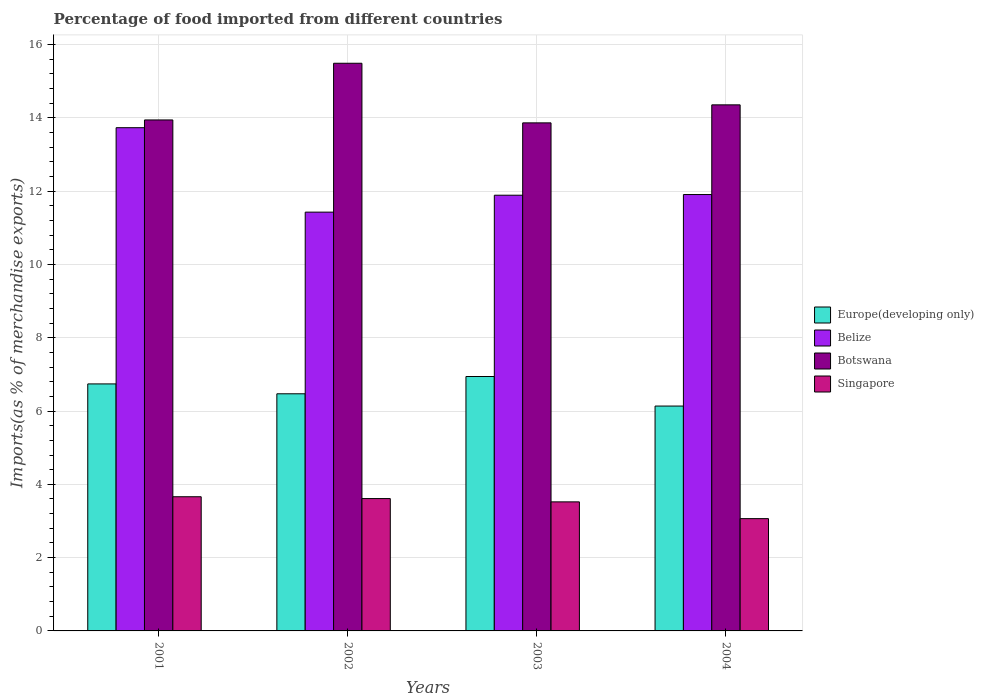How many groups of bars are there?
Give a very brief answer. 4. How many bars are there on the 4th tick from the left?
Ensure brevity in your answer.  4. What is the percentage of imports to different countries in Europe(developing only) in 2001?
Give a very brief answer. 6.74. Across all years, what is the maximum percentage of imports to different countries in Belize?
Keep it short and to the point. 13.73. Across all years, what is the minimum percentage of imports to different countries in Belize?
Provide a short and direct response. 11.43. In which year was the percentage of imports to different countries in Europe(developing only) minimum?
Provide a short and direct response. 2004. What is the total percentage of imports to different countries in Belize in the graph?
Make the answer very short. 48.96. What is the difference between the percentage of imports to different countries in Europe(developing only) in 2002 and that in 2004?
Provide a succinct answer. 0.33. What is the difference between the percentage of imports to different countries in Singapore in 2003 and the percentage of imports to different countries in Europe(developing only) in 2002?
Ensure brevity in your answer.  -2.95. What is the average percentage of imports to different countries in Europe(developing only) per year?
Provide a short and direct response. 6.57. In the year 2001, what is the difference between the percentage of imports to different countries in Belize and percentage of imports to different countries in Singapore?
Your answer should be very brief. 10.07. In how many years, is the percentage of imports to different countries in Belize greater than 13.6 %?
Your answer should be very brief. 1. What is the ratio of the percentage of imports to different countries in Belize in 2001 to that in 2003?
Your answer should be compact. 1.15. What is the difference between the highest and the second highest percentage of imports to different countries in Singapore?
Make the answer very short. 0.05. What is the difference between the highest and the lowest percentage of imports to different countries in Botswana?
Your answer should be very brief. 1.63. Is it the case that in every year, the sum of the percentage of imports to different countries in Botswana and percentage of imports to different countries in Belize is greater than the sum of percentage of imports to different countries in Singapore and percentage of imports to different countries in Europe(developing only)?
Provide a short and direct response. Yes. What does the 3rd bar from the left in 2003 represents?
Offer a very short reply. Botswana. What does the 4th bar from the right in 2002 represents?
Give a very brief answer. Europe(developing only). What is the difference between two consecutive major ticks on the Y-axis?
Keep it short and to the point. 2. Does the graph contain any zero values?
Keep it short and to the point. No. Does the graph contain grids?
Provide a short and direct response. Yes. Where does the legend appear in the graph?
Provide a short and direct response. Center right. What is the title of the graph?
Your answer should be compact. Percentage of food imported from different countries. What is the label or title of the X-axis?
Give a very brief answer. Years. What is the label or title of the Y-axis?
Offer a very short reply. Imports(as % of merchandise exports). What is the Imports(as % of merchandise exports) in Europe(developing only) in 2001?
Your answer should be very brief. 6.74. What is the Imports(as % of merchandise exports) of Belize in 2001?
Your answer should be very brief. 13.73. What is the Imports(as % of merchandise exports) of Botswana in 2001?
Give a very brief answer. 13.94. What is the Imports(as % of merchandise exports) of Singapore in 2001?
Offer a terse response. 3.66. What is the Imports(as % of merchandise exports) in Europe(developing only) in 2002?
Provide a succinct answer. 6.47. What is the Imports(as % of merchandise exports) of Belize in 2002?
Your response must be concise. 11.43. What is the Imports(as % of merchandise exports) of Botswana in 2002?
Your answer should be compact. 15.49. What is the Imports(as % of merchandise exports) of Singapore in 2002?
Your response must be concise. 3.61. What is the Imports(as % of merchandise exports) of Europe(developing only) in 2003?
Your response must be concise. 6.94. What is the Imports(as % of merchandise exports) of Belize in 2003?
Provide a succinct answer. 11.89. What is the Imports(as % of merchandise exports) in Botswana in 2003?
Your answer should be compact. 13.86. What is the Imports(as % of merchandise exports) in Singapore in 2003?
Provide a succinct answer. 3.52. What is the Imports(as % of merchandise exports) of Europe(developing only) in 2004?
Your answer should be compact. 6.14. What is the Imports(as % of merchandise exports) of Belize in 2004?
Offer a terse response. 11.91. What is the Imports(as % of merchandise exports) in Botswana in 2004?
Offer a terse response. 14.36. What is the Imports(as % of merchandise exports) in Singapore in 2004?
Your answer should be very brief. 3.06. Across all years, what is the maximum Imports(as % of merchandise exports) in Europe(developing only)?
Your response must be concise. 6.94. Across all years, what is the maximum Imports(as % of merchandise exports) of Belize?
Your response must be concise. 13.73. Across all years, what is the maximum Imports(as % of merchandise exports) of Botswana?
Make the answer very short. 15.49. Across all years, what is the maximum Imports(as % of merchandise exports) in Singapore?
Ensure brevity in your answer.  3.66. Across all years, what is the minimum Imports(as % of merchandise exports) in Europe(developing only)?
Provide a short and direct response. 6.14. Across all years, what is the minimum Imports(as % of merchandise exports) of Belize?
Ensure brevity in your answer.  11.43. Across all years, what is the minimum Imports(as % of merchandise exports) of Botswana?
Ensure brevity in your answer.  13.86. Across all years, what is the minimum Imports(as % of merchandise exports) in Singapore?
Give a very brief answer. 3.06. What is the total Imports(as % of merchandise exports) of Europe(developing only) in the graph?
Offer a very short reply. 26.29. What is the total Imports(as % of merchandise exports) in Belize in the graph?
Offer a terse response. 48.96. What is the total Imports(as % of merchandise exports) of Botswana in the graph?
Provide a short and direct response. 57.65. What is the total Imports(as % of merchandise exports) of Singapore in the graph?
Provide a succinct answer. 13.86. What is the difference between the Imports(as % of merchandise exports) of Europe(developing only) in 2001 and that in 2002?
Make the answer very short. 0.27. What is the difference between the Imports(as % of merchandise exports) of Belize in 2001 and that in 2002?
Your response must be concise. 2.3. What is the difference between the Imports(as % of merchandise exports) in Botswana in 2001 and that in 2002?
Provide a succinct answer. -1.55. What is the difference between the Imports(as % of merchandise exports) of Singapore in 2001 and that in 2002?
Your answer should be very brief. 0.05. What is the difference between the Imports(as % of merchandise exports) in Europe(developing only) in 2001 and that in 2003?
Make the answer very short. -0.2. What is the difference between the Imports(as % of merchandise exports) of Belize in 2001 and that in 2003?
Your answer should be very brief. 1.84. What is the difference between the Imports(as % of merchandise exports) of Botswana in 2001 and that in 2003?
Keep it short and to the point. 0.08. What is the difference between the Imports(as % of merchandise exports) of Singapore in 2001 and that in 2003?
Give a very brief answer. 0.14. What is the difference between the Imports(as % of merchandise exports) of Europe(developing only) in 2001 and that in 2004?
Offer a very short reply. 0.6. What is the difference between the Imports(as % of merchandise exports) in Belize in 2001 and that in 2004?
Provide a succinct answer. 1.82. What is the difference between the Imports(as % of merchandise exports) in Botswana in 2001 and that in 2004?
Provide a succinct answer. -0.41. What is the difference between the Imports(as % of merchandise exports) in Singapore in 2001 and that in 2004?
Your answer should be very brief. 0.6. What is the difference between the Imports(as % of merchandise exports) of Europe(developing only) in 2002 and that in 2003?
Keep it short and to the point. -0.47. What is the difference between the Imports(as % of merchandise exports) of Belize in 2002 and that in 2003?
Your answer should be compact. -0.46. What is the difference between the Imports(as % of merchandise exports) of Botswana in 2002 and that in 2003?
Give a very brief answer. 1.63. What is the difference between the Imports(as % of merchandise exports) of Singapore in 2002 and that in 2003?
Keep it short and to the point. 0.09. What is the difference between the Imports(as % of merchandise exports) in Europe(developing only) in 2002 and that in 2004?
Offer a very short reply. 0.33. What is the difference between the Imports(as % of merchandise exports) of Belize in 2002 and that in 2004?
Provide a succinct answer. -0.48. What is the difference between the Imports(as % of merchandise exports) of Botswana in 2002 and that in 2004?
Offer a terse response. 1.14. What is the difference between the Imports(as % of merchandise exports) of Singapore in 2002 and that in 2004?
Your answer should be compact. 0.55. What is the difference between the Imports(as % of merchandise exports) of Europe(developing only) in 2003 and that in 2004?
Your answer should be compact. 0.81. What is the difference between the Imports(as % of merchandise exports) of Belize in 2003 and that in 2004?
Keep it short and to the point. -0.02. What is the difference between the Imports(as % of merchandise exports) of Botswana in 2003 and that in 2004?
Provide a short and direct response. -0.49. What is the difference between the Imports(as % of merchandise exports) in Singapore in 2003 and that in 2004?
Your answer should be compact. 0.46. What is the difference between the Imports(as % of merchandise exports) in Europe(developing only) in 2001 and the Imports(as % of merchandise exports) in Belize in 2002?
Offer a very short reply. -4.69. What is the difference between the Imports(as % of merchandise exports) of Europe(developing only) in 2001 and the Imports(as % of merchandise exports) of Botswana in 2002?
Ensure brevity in your answer.  -8.75. What is the difference between the Imports(as % of merchandise exports) of Europe(developing only) in 2001 and the Imports(as % of merchandise exports) of Singapore in 2002?
Give a very brief answer. 3.13. What is the difference between the Imports(as % of merchandise exports) of Belize in 2001 and the Imports(as % of merchandise exports) of Botswana in 2002?
Provide a short and direct response. -1.76. What is the difference between the Imports(as % of merchandise exports) in Belize in 2001 and the Imports(as % of merchandise exports) in Singapore in 2002?
Make the answer very short. 10.12. What is the difference between the Imports(as % of merchandise exports) of Botswana in 2001 and the Imports(as % of merchandise exports) of Singapore in 2002?
Ensure brevity in your answer.  10.33. What is the difference between the Imports(as % of merchandise exports) in Europe(developing only) in 2001 and the Imports(as % of merchandise exports) in Belize in 2003?
Your answer should be compact. -5.15. What is the difference between the Imports(as % of merchandise exports) in Europe(developing only) in 2001 and the Imports(as % of merchandise exports) in Botswana in 2003?
Your answer should be compact. -7.12. What is the difference between the Imports(as % of merchandise exports) in Europe(developing only) in 2001 and the Imports(as % of merchandise exports) in Singapore in 2003?
Provide a succinct answer. 3.22. What is the difference between the Imports(as % of merchandise exports) of Belize in 2001 and the Imports(as % of merchandise exports) of Botswana in 2003?
Offer a terse response. -0.13. What is the difference between the Imports(as % of merchandise exports) in Belize in 2001 and the Imports(as % of merchandise exports) in Singapore in 2003?
Keep it short and to the point. 10.21. What is the difference between the Imports(as % of merchandise exports) in Botswana in 2001 and the Imports(as % of merchandise exports) in Singapore in 2003?
Provide a short and direct response. 10.42. What is the difference between the Imports(as % of merchandise exports) of Europe(developing only) in 2001 and the Imports(as % of merchandise exports) of Belize in 2004?
Offer a very short reply. -5.17. What is the difference between the Imports(as % of merchandise exports) of Europe(developing only) in 2001 and the Imports(as % of merchandise exports) of Botswana in 2004?
Provide a succinct answer. -7.61. What is the difference between the Imports(as % of merchandise exports) of Europe(developing only) in 2001 and the Imports(as % of merchandise exports) of Singapore in 2004?
Your answer should be compact. 3.68. What is the difference between the Imports(as % of merchandise exports) of Belize in 2001 and the Imports(as % of merchandise exports) of Botswana in 2004?
Your answer should be very brief. -0.62. What is the difference between the Imports(as % of merchandise exports) in Belize in 2001 and the Imports(as % of merchandise exports) in Singapore in 2004?
Your answer should be compact. 10.67. What is the difference between the Imports(as % of merchandise exports) of Botswana in 2001 and the Imports(as % of merchandise exports) of Singapore in 2004?
Give a very brief answer. 10.88. What is the difference between the Imports(as % of merchandise exports) of Europe(developing only) in 2002 and the Imports(as % of merchandise exports) of Belize in 2003?
Provide a short and direct response. -5.42. What is the difference between the Imports(as % of merchandise exports) of Europe(developing only) in 2002 and the Imports(as % of merchandise exports) of Botswana in 2003?
Offer a very short reply. -7.39. What is the difference between the Imports(as % of merchandise exports) in Europe(developing only) in 2002 and the Imports(as % of merchandise exports) in Singapore in 2003?
Your answer should be compact. 2.95. What is the difference between the Imports(as % of merchandise exports) in Belize in 2002 and the Imports(as % of merchandise exports) in Botswana in 2003?
Ensure brevity in your answer.  -2.44. What is the difference between the Imports(as % of merchandise exports) in Belize in 2002 and the Imports(as % of merchandise exports) in Singapore in 2003?
Offer a terse response. 7.91. What is the difference between the Imports(as % of merchandise exports) of Botswana in 2002 and the Imports(as % of merchandise exports) of Singapore in 2003?
Ensure brevity in your answer.  11.97. What is the difference between the Imports(as % of merchandise exports) in Europe(developing only) in 2002 and the Imports(as % of merchandise exports) in Belize in 2004?
Provide a short and direct response. -5.44. What is the difference between the Imports(as % of merchandise exports) of Europe(developing only) in 2002 and the Imports(as % of merchandise exports) of Botswana in 2004?
Your answer should be compact. -7.88. What is the difference between the Imports(as % of merchandise exports) in Europe(developing only) in 2002 and the Imports(as % of merchandise exports) in Singapore in 2004?
Ensure brevity in your answer.  3.41. What is the difference between the Imports(as % of merchandise exports) in Belize in 2002 and the Imports(as % of merchandise exports) in Botswana in 2004?
Make the answer very short. -2.93. What is the difference between the Imports(as % of merchandise exports) in Belize in 2002 and the Imports(as % of merchandise exports) in Singapore in 2004?
Provide a short and direct response. 8.36. What is the difference between the Imports(as % of merchandise exports) in Botswana in 2002 and the Imports(as % of merchandise exports) in Singapore in 2004?
Provide a short and direct response. 12.43. What is the difference between the Imports(as % of merchandise exports) in Europe(developing only) in 2003 and the Imports(as % of merchandise exports) in Belize in 2004?
Keep it short and to the point. -4.97. What is the difference between the Imports(as % of merchandise exports) in Europe(developing only) in 2003 and the Imports(as % of merchandise exports) in Botswana in 2004?
Provide a short and direct response. -7.41. What is the difference between the Imports(as % of merchandise exports) in Europe(developing only) in 2003 and the Imports(as % of merchandise exports) in Singapore in 2004?
Give a very brief answer. 3.88. What is the difference between the Imports(as % of merchandise exports) in Belize in 2003 and the Imports(as % of merchandise exports) in Botswana in 2004?
Give a very brief answer. -2.47. What is the difference between the Imports(as % of merchandise exports) in Belize in 2003 and the Imports(as % of merchandise exports) in Singapore in 2004?
Make the answer very short. 8.83. What is the difference between the Imports(as % of merchandise exports) of Botswana in 2003 and the Imports(as % of merchandise exports) of Singapore in 2004?
Offer a very short reply. 10.8. What is the average Imports(as % of merchandise exports) in Europe(developing only) per year?
Provide a short and direct response. 6.57. What is the average Imports(as % of merchandise exports) of Belize per year?
Offer a very short reply. 12.24. What is the average Imports(as % of merchandise exports) in Botswana per year?
Your answer should be compact. 14.41. What is the average Imports(as % of merchandise exports) in Singapore per year?
Your response must be concise. 3.46. In the year 2001, what is the difference between the Imports(as % of merchandise exports) of Europe(developing only) and Imports(as % of merchandise exports) of Belize?
Your answer should be compact. -6.99. In the year 2001, what is the difference between the Imports(as % of merchandise exports) of Europe(developing only) and Imports(as % of merchandise exports) of Botswana?
Provide a short and direct response. -7.2. In the year 2001, what is the difference between the Imports(as % of merchandise exports) in Europe(developing only) and Imports(as % of merchandise exports) in Singapore?
Your answer should be very brief. 3.08. In the year 2001, what is the difference between the Imports(as % of merchandise exports) in Belize and Imports(as % of merchandise exports) in Botswana?
Provide a short and direct response. -0.21. In the year 2001, what is the difference between the Imports(as % of merchandise exports) of Belize and Imports(as % of merchandise exports) of Singapore?
Ensure brevity in your answer.  10.07. In the year 2001, what is the difference between the Imports(as % of merchandise exports) of Botswana and Imports(as % of merchandise exports) of Singapore?
Your answer should be very brief. 10.28. In the year 2002, what is the difference between the Imports(as % of merchandise exports) of Europe(developing only) and Imports(as % of merchandise exports) of Belize?
Provide a succinct answer. -4.96. In the year 2002, what is the difference between the Imports(as % of merchandise exports) in Europe(developing only) and Imports(as % of merchandise exports) in Botswana?
Your answer should be compact. -9.02. In the year 2002, what is the difference between the Imports(as % of merchandise exports) in Europe(developing only) and Imports(as % of merchandise exports) in Singapore?
Ensure brevity in your answer.  2.86. In the year 2002, what is the difference between the Imports(as % of merchandise exports) of Belize and Imports(as % of merchandise exports) of Botswana?
Keep it short and to the point. -4.06. In the year 2002, what is the difference between the Imports(as % of merchandise exports) in Belize and Imports(as % of merchandise exports) in Singapore?
Ensure brevity in your answer.  7.82. In the year 2002, what is the difference between the Imports(as % of merchandise exports) in Botswana and Imports(as % of merchandise exports) in Singapore?
Provide a short and direct response. 11.88. In the year 2003, what is the difference between the Imports(as % of merchandise exports) of Europe(developing only) and Imports(as % of merchandise exports) of Belize?
Give a very brief answer. -4.95. In the year 2003, what is the difference between the Imports(as % of merchandise exports) of Europe(developing only) and Imports(as % of merchandise exports) of Botswana?
Your answer should be very brief. -6.92. In the year 2003, what is the difference between the Imports(as % of merchandise exports) of Europe(developing only) and Imports(as % of merchandise exports) of Singapore?
Your answer should be very brief. 3.42. In the year 2003, what is the difference between the Imports(as % of merchandise exports) of Belize and Imports(as % of merchandise exports) of Botswana?
Provide a succinct answer. -1.97. In the year 2003, what is the difference between the Imports(as % of merchandise exports) of Belize and Imports(as % of merchandise exports) of Singapore?
Provide a short and direct response. 8.37. In the year 2003, what is the difference between the Imports(as % of merchandise exports) of Botswana and Imports(as % of merchandise exports) of Singapore?
Your answer should be very brief. 10.34. In the year 2004, what is the difference between the Imports(as % of merchandise exports) of Europe(developing only) and Imports(as % of merchandise exports) of Belize?
Make the answer very short. -5.77. In the year 2004, what is the difference between the Imports(as % of merchandise exports) in Europe(developing only) and Imports(as % of merchandise exports) in Botswana?
Your response must be concise. -8.22. In the year 2004, what is the difference between the Imports(as % of merchandise exports) of Europe(developing only) and Imports(as % of merchandise exports) of Singapore?
Provide a short and direct response. 3.07. In the year 2004, what is the difference between the Imports(as % of merchandise exports) of Belize and Imports(as % of merchandise exports) of Botswana?
Offer a terse response. -2.45. In the year 2004, what is the difference between the Imports(as % of merchandise exports) of Belize and Imports(as % of merchandise exports) of Singapore?
Give a very brief answer. 8.84. In the year 2004, what is the difference between the Imports(as % of merchandise exports) of Botswana and Imports(as % of merchandise exports) of Singapore?
Your answer should be compact. 11.29. What is the ratio of the Imports(as % of merchandise exports) in Europe(developing only) in 2001 to that in 2002?
Offer a terse response. 1.04. What is the ratio of the Imports(as % of merchandise exports) in Belize in 2001 to that in 2002?
Provide a succinct answer. 1.2. What is the ratio of the Imports(as % of merchandise exports) of Botswana in 2001 to that in 2002?
Your answer should be very brief. 0.9. What is the ratio of the Imports(as % of merchandise exports) of Singapore in 2001 to that in 2002?
Provide a succinct answer. 1.01. What is the ratio of the Imports(as % of merchandise exports) in Europe(developing only) in 2001 to that in 2003?
Make the answer very short. 0.97. What is the ratio of the Imports(as % of merchandise exports) of Belize in 2001 to that in 2003?
Provide a succinct answer. 1.16. What is the ratio of the Imports(as % of merchandise exports) of Botswana in 2001 to that in 2003?
Your response must be concise. 1.01. What is the ratio of the Imports(as % of merchandise exports) of Singapore in 2001 to that in 2003?
Offer a terse response. 1.04. What is the ratio of the Imports(as % of merchandise exports) of Europe(developing only) in 2001 to that in 2004?
Give a very brief answer. 1.1. What is the ratio of the Imports(as % of merchandise exports) of Belize in 2001 to that in 2004?
Your response must be concise. 1.15. What is the ratio of the Imports(as % of merchandise exports) in Botswana in 2001 to that in 2004?
Your answer should be very brief. 0.97. What is the ratio of the Imports(as % of merchandise exports) in Singapore in 2001 to that in 2004?
Your answer should be compact. 1.19. What is the ratio of the Imports(as % of merchandise exports) of Europe(developing only) in 2002 to that in 2003?
Provide a short and direct response. 0.93. What is the ratio of the Imports(as % of merchandise exports) in Belize in 2002 to that in 2003?
Offer a terse response. 0.96. What is the ratio of the Imports(as % of merchandise exports) of Botswana in 2002 to that in 2003?
Your response must be concise. 1.12. What is the ratio of the Imports(as % of merchandise exports) of Singapore in 2002 to that in 2003?
Offer a terse response. 1.03. What is the ratio of the Imports(as % of merchandise exports) in Europe(developing only) in 2002 to that in 2004?
Provide a succinct answer. 1.05. What is the ratio of the Imports(as % of merchandise exports) of Belize in 2002 to that in 2004?
Offer a terse response. 0.96. What is the ratio of the Imports(as % of merchandise exports) of Botswana in 2002 to that in 2004?
Your answer should be compact. 1.08. What is the ratio of the Imports(as % of merchandise exports) in Singapore in 2002 to that in 2004?
Give a very brief answer. 1.18. What is the ratio of the Imports(as % of merchandise exports) in Europe(developing only) in 2003 to that in 2004?
Offer a very short reply. 1.13. What is the ratio of the Imports(as % of merchandise exports) in Botswana in 2003 to that in 2004?
Offer a terse response. 0.97. What is the ratio of the Imports(as % of merchandise exports) of Singapore in 2003 to that in 2004?
Keep it short and to the point. 1.15. What is the difference between the highest and the second highest Imports(as % of merchandise exports) in Europe(developing only)?
Offer a terse response. 0.2. What is the difference between the highest and the second highest Imports(as % of merchandise exports) of Belize?
Your response must be concise. 1.82. What is the difference between the highest and the second highest Imports(as % of merchandise exports) of Botswana?
Keep it short and to the point. 1.14. What is the difference between the highest and the second highest Imports(as % of merchandise exports) in Singapore?
Offer a very short reply. 0.05. What is the difference between the highest and the lowest Imports(as % of merchandise exports) of Europe(developing only)?
Ensure brevity in your answer.  0.81. What is the difference between the highest and the lowest Imports(as % of merchandise exports) in Belize?
Make the answer very short. 2.3. What is the difference between the highest and the lowest Imports(as % of merchandise exports) of Botswana?
Provide a short and direct response. 1.63. What is the difference between the highest and the lowest Imports(as % of merchandise exports) in Singapore?
Your response must be concise. 0.6. 